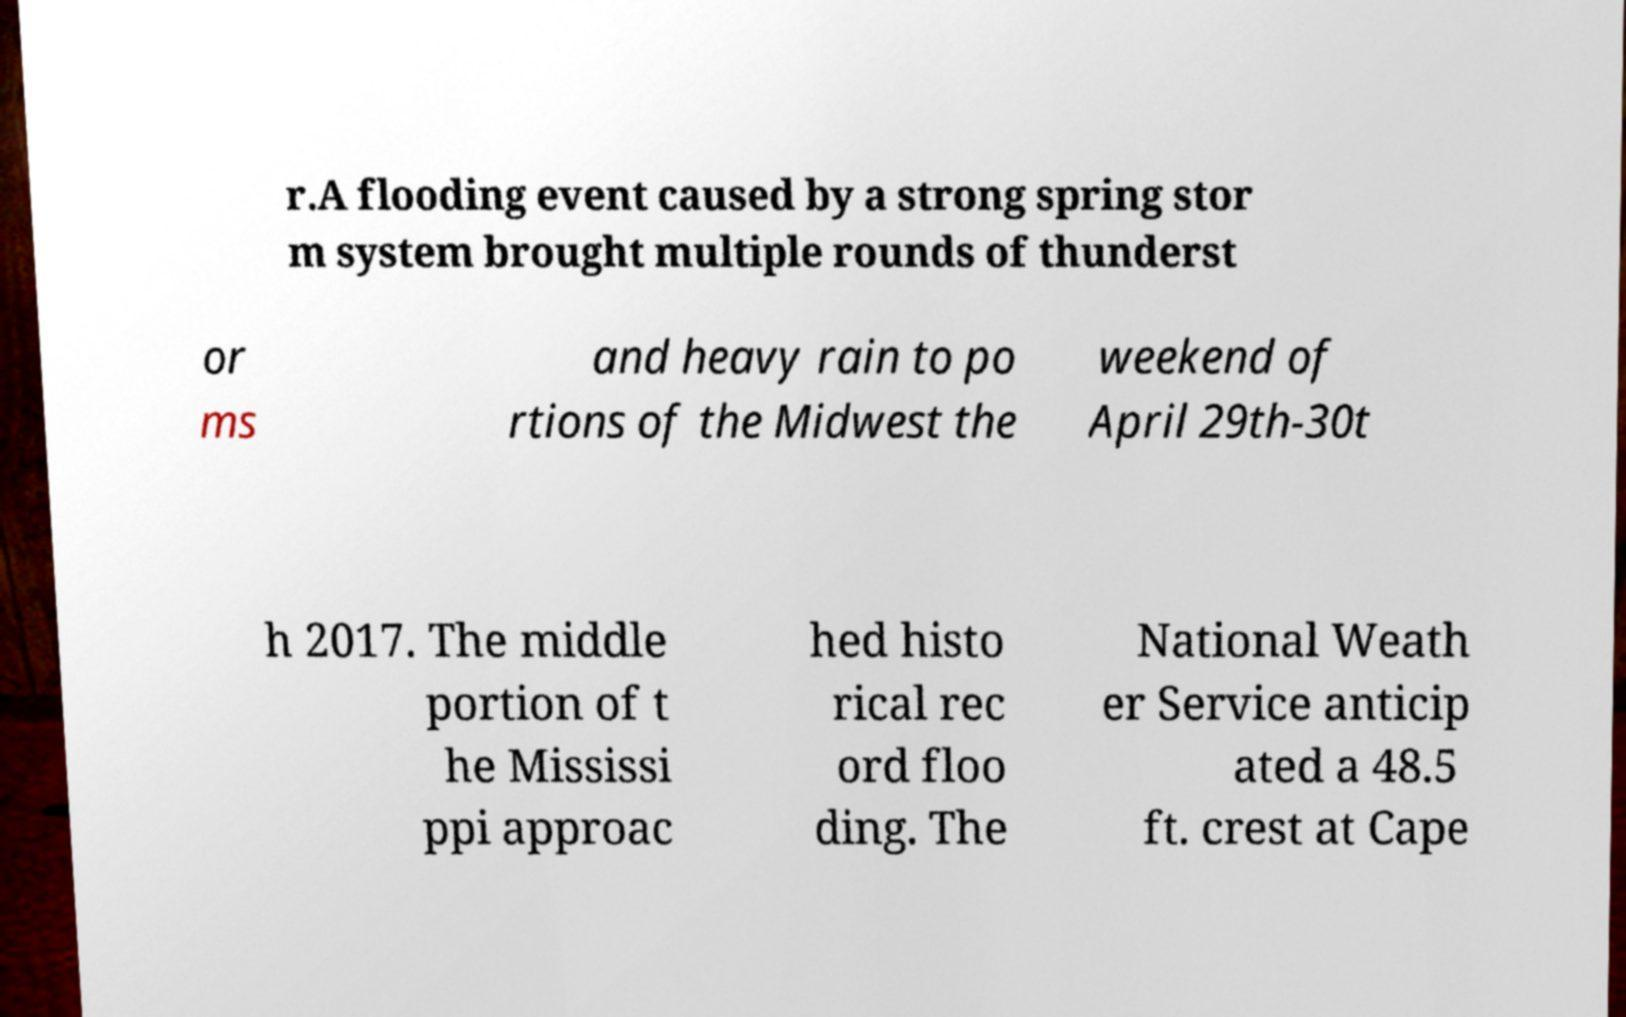Please identify and transcribe the text found in this image. r.A flooding event caused by a strong spring stor m system brought multiple rounds of thunderst or ms and heavy rain to po rtions of the Midwest the weekend of April 29th-30t h 2017. The middle portion of t he Mississi ppi approac hed histo rical rec ord floo ding. The National Weath er Service anticip ated a 48.5 ft. crest at Cape 